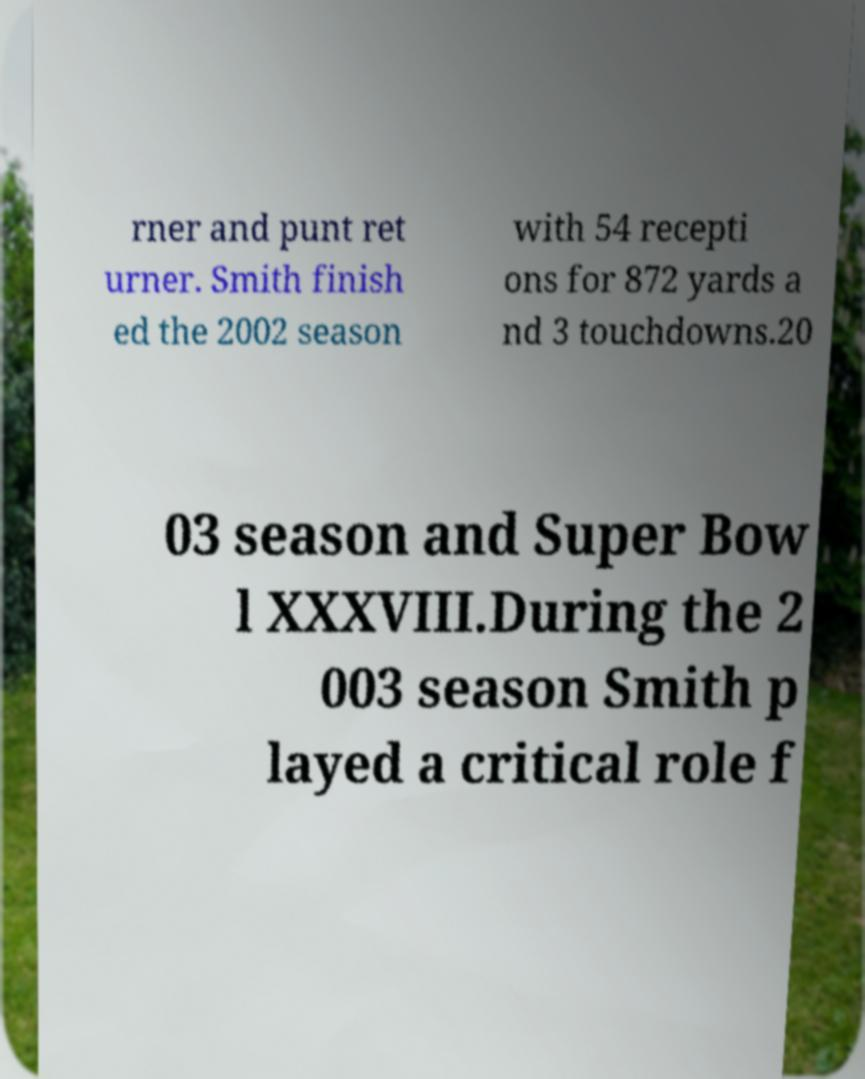I need the written content from this picture converted into text. Can you do that? rner and punt ret urner. Smith finish ed the 2002 season with 54 recepti ons for 872 yards a nd 3 touchdowns.20 03 season and Super Bow l XXXVIII.During the 2 003 season Smith p layed a critical role f 